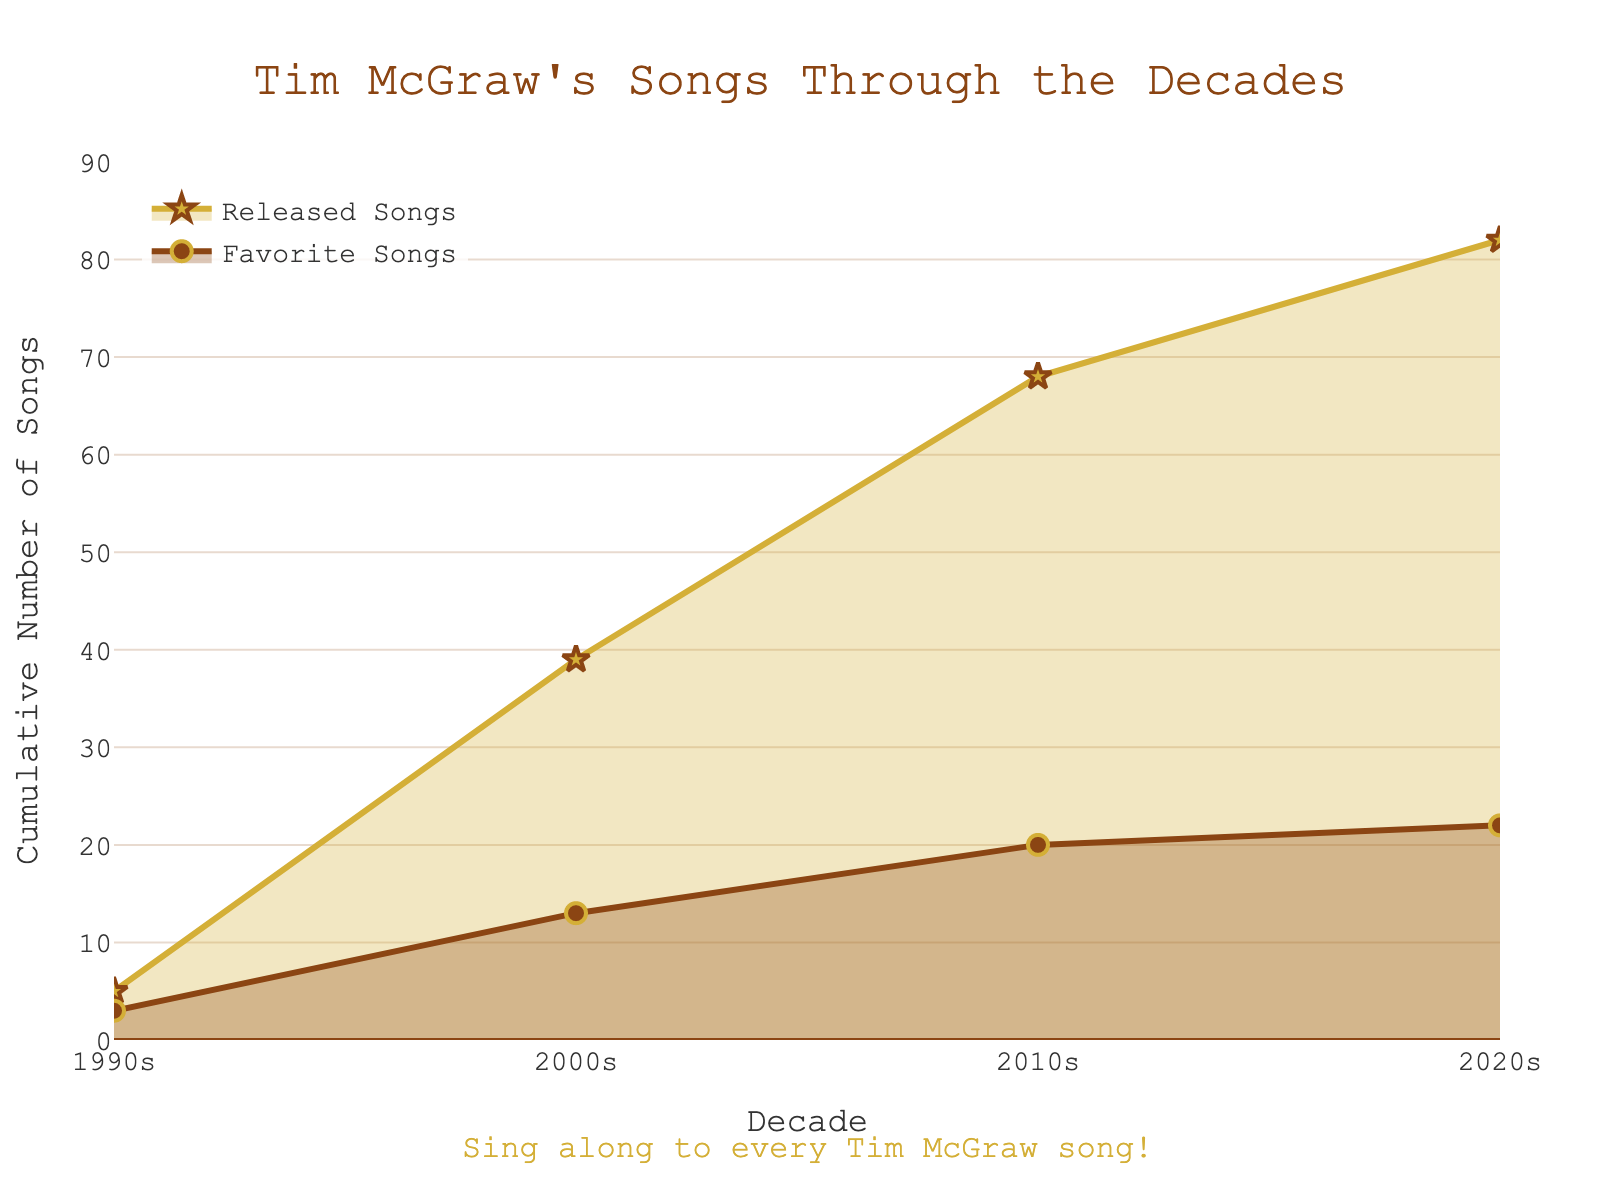What's the title of the plot? The title is displayed prominently at the top of the plot and reads "Tim McGraw's Songs Through the Decades"
Answer: Tim McGraw's Songs Through the Decades How many favorite songs were released in the 2000s? Look at the point corresponding to the 2000s and observe the cumulative number of favorite songs, which is 10.
Answer: 10 In which decade were the fewest favorite songs released cumulatively? Compare the cumulative favorite songs for each decade: the 1990s, 2000s, 2010s, and 2020s. The decade with the fewest favorite songs is the 2020s with 2.
Answer: 2020s In which decade were the most songs released cumulatively? Analyze the cumulative released songs for each decade: 1990s, 2000s, 2010s, and 2020s. The decade with the highest cumulative number of released songs is the 2000s, with 39.
Answer: 2000s What's the difference in the number of cumulative favorite songs between the 2010s and the 2020s? Subtract the cumulative favorite songs in the 2020s (2) from those in the 2010s (19). The difference is 7 - 2 = 5.
Answer: 5 What is the cumulative number of released songs by the end of the 2010s? Look at the plot where the line for released songs intersects with the 2010s. The cumulative number of released songs is 68.
Answer: 68 How many favorite songs were released in total across all decades? Sum the cumulative favorite songs in all decades: 3 (1990s) + 10 (2000s) + 7 (2010s) + 2 (2020s) = 22.
Answer: 22 Did the number of cumulative favorite songs grow faster or slower than cumulative released songs from the 2000s to the 2010s? Observing the slopes of the lines, the cumulative favorite songs (from 10 to 17) have a less steep increase than the cumulative released songs (from 39 to 68).
Answer: Slower Which decade has a cumulative favorite songs count just before the peak in released songs? By inspecting the plot, the 2000s have the highest cumulative number of released songs (39) and the corresponding cumulative favorite songs is just before this peak, which is 10.
Answer: 2000s What is the approximate ratio of cumulative favorite songs to cumulative released songs in the 2010s? The cumulative number of favorite songs in the 2010s is 17 and the cumulative number of released songs is 68. So the ratio is 17/68 ≈ 0.25 (or 1:4).
Answer: 0.25 